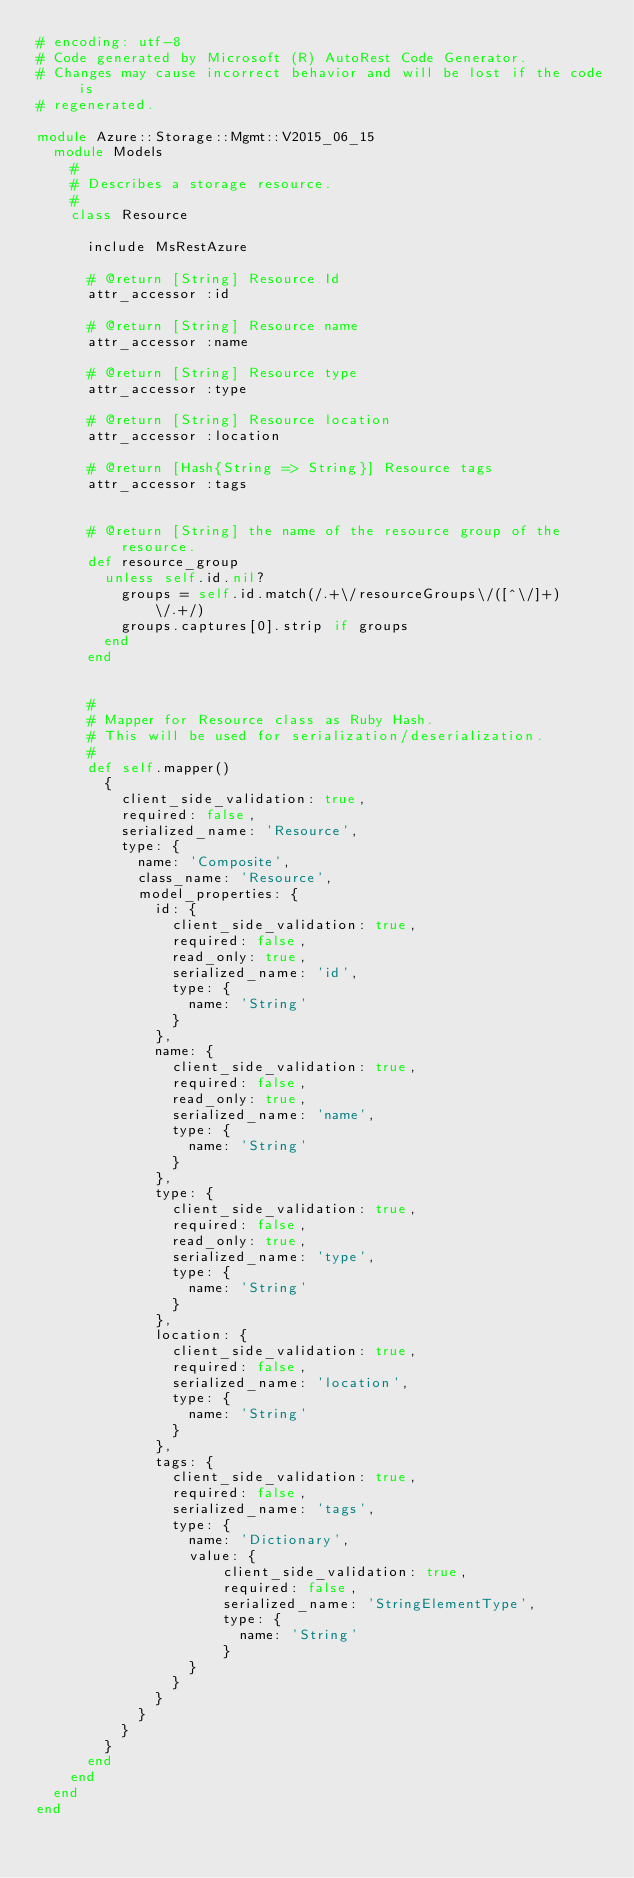Convert code to text. <code><loc_0><loc_0><loc_500><loc_500><_Ruby_># encoding: utf-8
# Code generated by Microsoft (R) AutoRest Code Generator.
# Changes may cause incorrect behavior and will be lost if the code is
# regenerated.

module Azure::Storage::Mgmt::V2015_06_15
  module Models
    #
    # Describes a storage resource.
    #
    class Resource

      include MsRestAzure

      # @return [String] Resource Id
      attr_accessor :id

      # @return [String] Resource name
      attr_accessor :name

      # @return [String] Resource type
      attr_accessor :type

      # @return [String] Resource location
      attr_accessor :location

      # @return [Hash{String => String}] Resource tags
      attr_accessor :tags


      # @return [String] the name of the resource group of the resource.
      def resource_group
        unless self.id.nil?
          groups = self.id.match(/.+\/resourceGroups\/([^\/]+)\/.+/)
          groups.captures[0].strip if groups
        end
      end


      #
      # Mapper for Resource class as Ruby Hash.
      # This will be used for serialization/deserialization.
      #
      def self.mapper()
        {
          client_side_validation: true,
          required: false,
          serialized_name: 'Resource',
          type: {
            name: 'Composite',
            class_name: 'Resource',
            model_properties: {
              id: {
                client_side_validation: true,
                required: false,
                read_only: true,
                serialized_name: 'id',
                type: {
                  name: 'String'
                }
              },
              name: {
                client_side_validation: true,
                required: false,
                read_only: true,
                serialized_name: 'name',
                type: {
                  name: 'String'
                }
              },
              type: {
                client_side_validation: true,
                required: false,
                read_only: true,
                serialized_name: 'type',
                type: {
                  name: 'String'
                }
              },
              location: {
                client_side_validation: true,
                required: false,
                serialized_name: 'location',
                type: {
                  name: 'String'
                }
              },
              tags: {
                client_side_validation: true,
                required: false,
                serialized_name: 'tags',
                type: {
                  name: 'Dictionary',
                  value: {
                      client_side_validation: true,
                      required: false,
                      serialized_name: 'StringElementType',
                      type: {
                        name: 'String'
                      }
                  }
                }
              }
            }
          }
        }
      end
    end
  end
end
</code> 